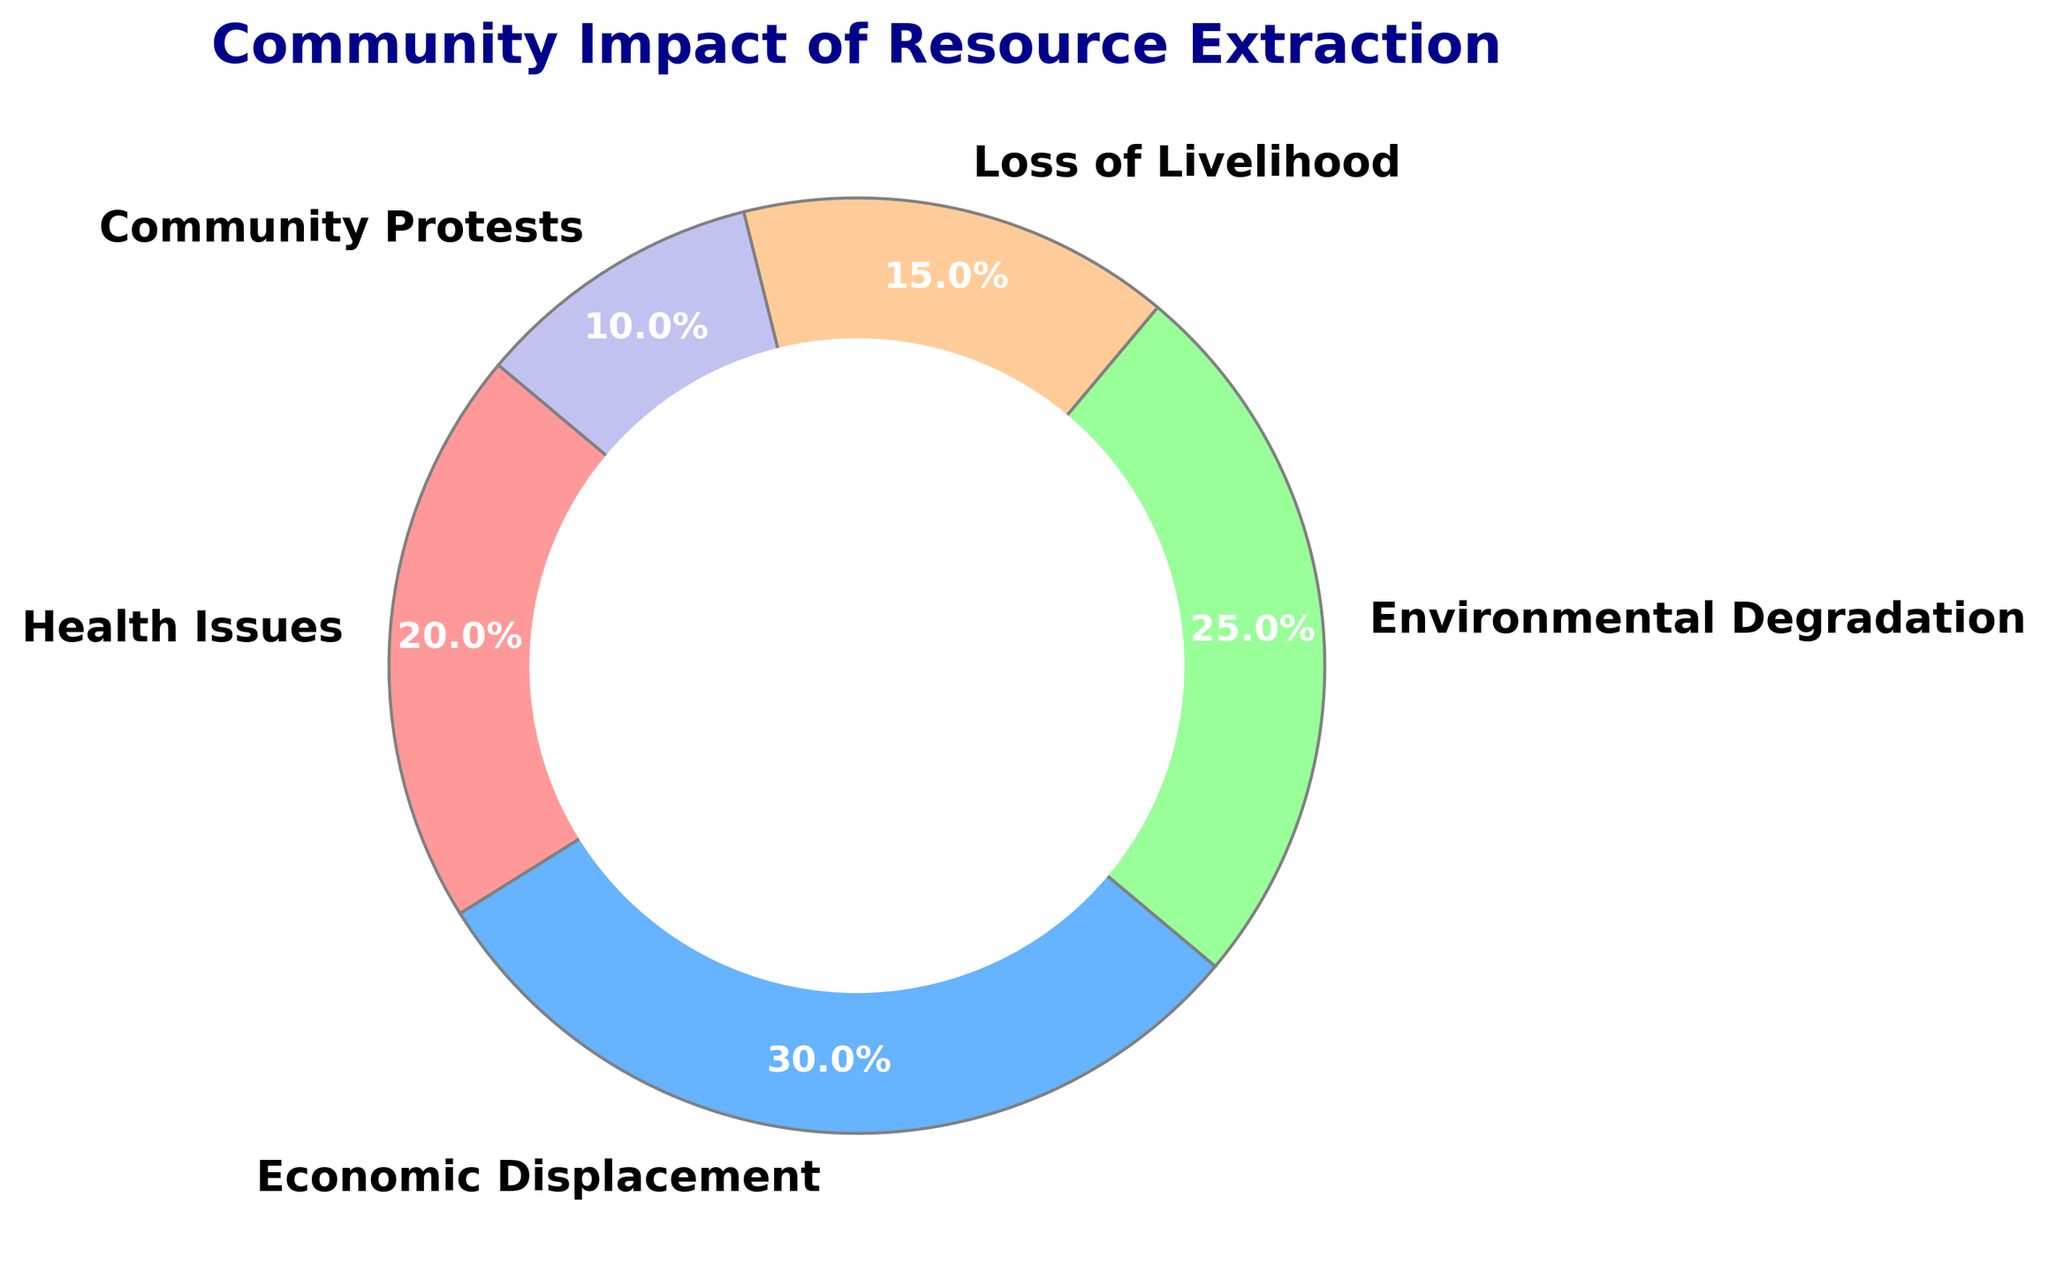Which category has the highest percentage? We need to look for the category with the largest slice in the pie chart. From the chart, Economic Displacement has the largest slice.
Answer: Economic Displacement What is the total percentage of Health Issues and Environmental Degradation? We add the percentage of Health Issues and Environmental Degradation. Health Issues is 20% and Environmental Degradation is 25%, so 20% + 25% = 45%.
Answer: 45% How much more is the percentage of Economic Displacement compared to Community Protests? We need to find the difference in percentage between Economic Displacement and Community Protests. Economic Displacement is 30% and Community Protests is 10%, so 30% - 10% = 20%.
Answer: 20% What color is used to represent Loss of Livelihood? We need to refer to the color coding in the pie chart to identify the color of the slice labeled as Loss of Livelihood. The color used for Loss of Livelihood is represented by the light orange slice.
Answer: Light orange Which categories collectively account for exactly half of the impact (50%)? We need to find categories that collectively sum to 50%. From the chart, Health Issues (20%) and Economic Displacement (30%) together make 20% + 30% = 50%.
Answer: Health Issues and Economic Displacement How many percentage points greater is Environmental Degradation compared to Loss of Livelihood? We subtract the percentage of Loss of Livelihood from Environmental Degradation. Environmental Degradation is 25% and Loss of Livelihood is 15%, so 25% - 15% = 10%.
Answer: 10% What is the total percentage contributed by categories with a percentage less than 25%? We count the categories with percentages less than 25%: Health Issues (20%), Loss of Livelihood (15%), and Community Protests (10%). Summing these we get 20% + 15% + 10% = 45%.
Answer: 45% Which category has the smallest impact on the community? We need to identify the category with the smallest slice in the pie chart. From the chart, Community Protests has the smallest slice at 10%.
Answer: Community Protests What is the difference in impact percentages between the most and least impactful categories? We find the difference between the highest percentage (Economic Displacement, 30%) and the lowest percentage (Community Protests, 10%). So, 30% - 10% = 20%.
Answer: 20% Which categories are represented by slices with cool colors (blue, green, or similar)? We need to identify the categories with blue or green slices. From the chart, Economic Displacement (blue) and Environmental Degradation (green) fit this description.
Answer: Economic Displacement and Environmental Degradation 